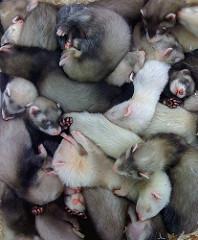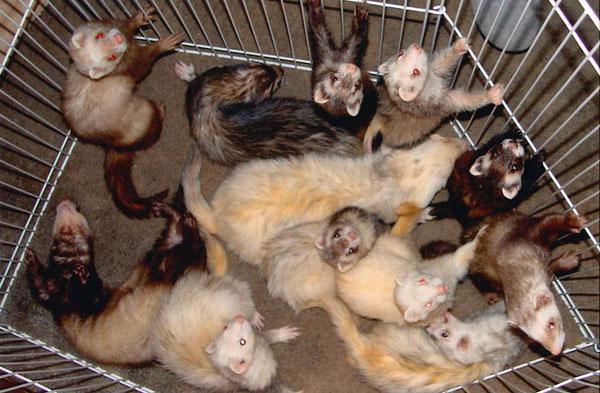The first image is the image on the left, the second image is the image on the right. Analyze the images presented: Is the assertion "The right image contains one ferret emerging from a hole in the dirt." valid? Answer yes or no. No. 